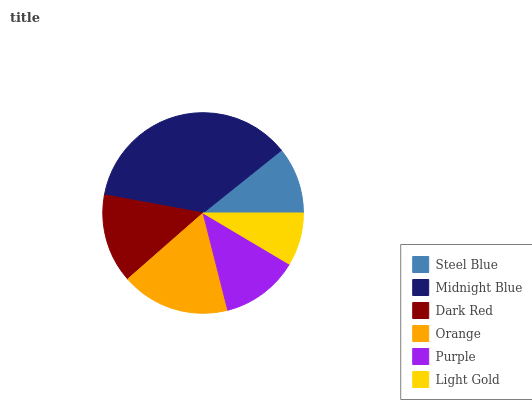Is Light Gold the minimum?
Answer yes or no. Yes. Is Midnight Blue the maximum?
Answer yes or no. Yes. Is Dark Red the minimum?
Answer yes or no. No. Is Dark Red the maximum?
Answer yes or no. No. Is Midnight Blue greater than Dark Red?
Answer yes or no. Yes. Is Dark Red less than Midnight Blue?
Answer yes or no. Yes. Is Dark Red greater than Midnight Blue?
Answer yes or no. No. Is Midnight Blue less than Dark Red?
Answer yes or no. No. Is Dark Red the high median?
Answer yes or no. Yes. Is Purple the low median?
Answer yes or no. Yes. Is Light Gold the high median?
Answer yes or no. No. Is Dark Red the low median?
Answer yes or no. No. 